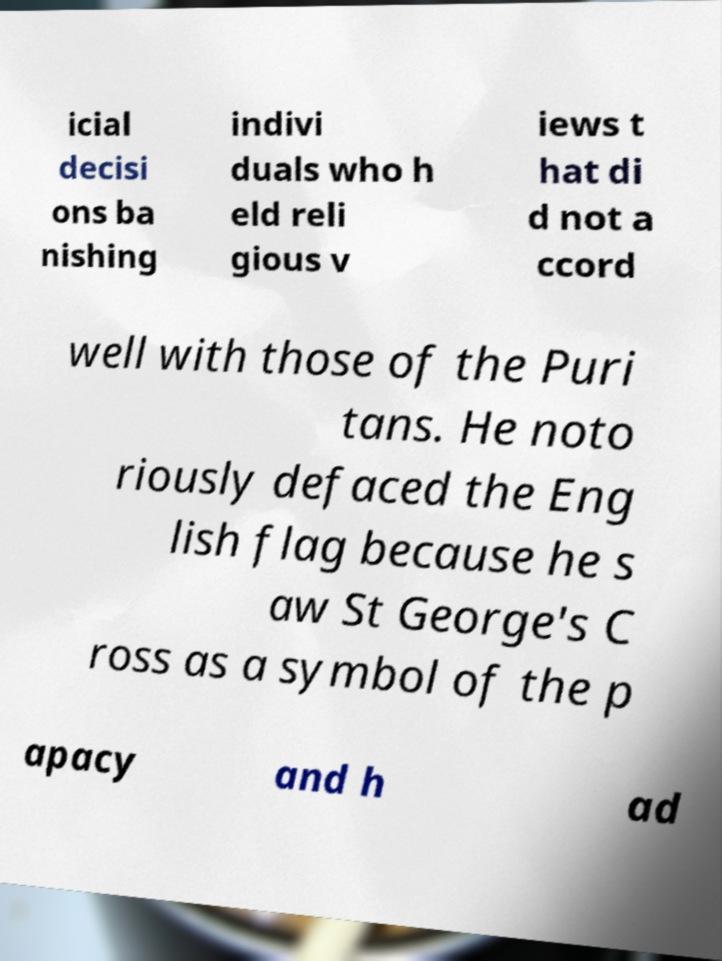Can you read and provide the text displayed in the image?This photo seems to have some interesting text. Can you extract and type it out for me? icial decisi ons ba nishing indivi duals who h eld reli gious v iews t hat di d not a ccord well with those of the Puri tans. He noto riously defaced the Eng lish flag because he s aw St George's C ross as a symbol of the p apacy and h ad 